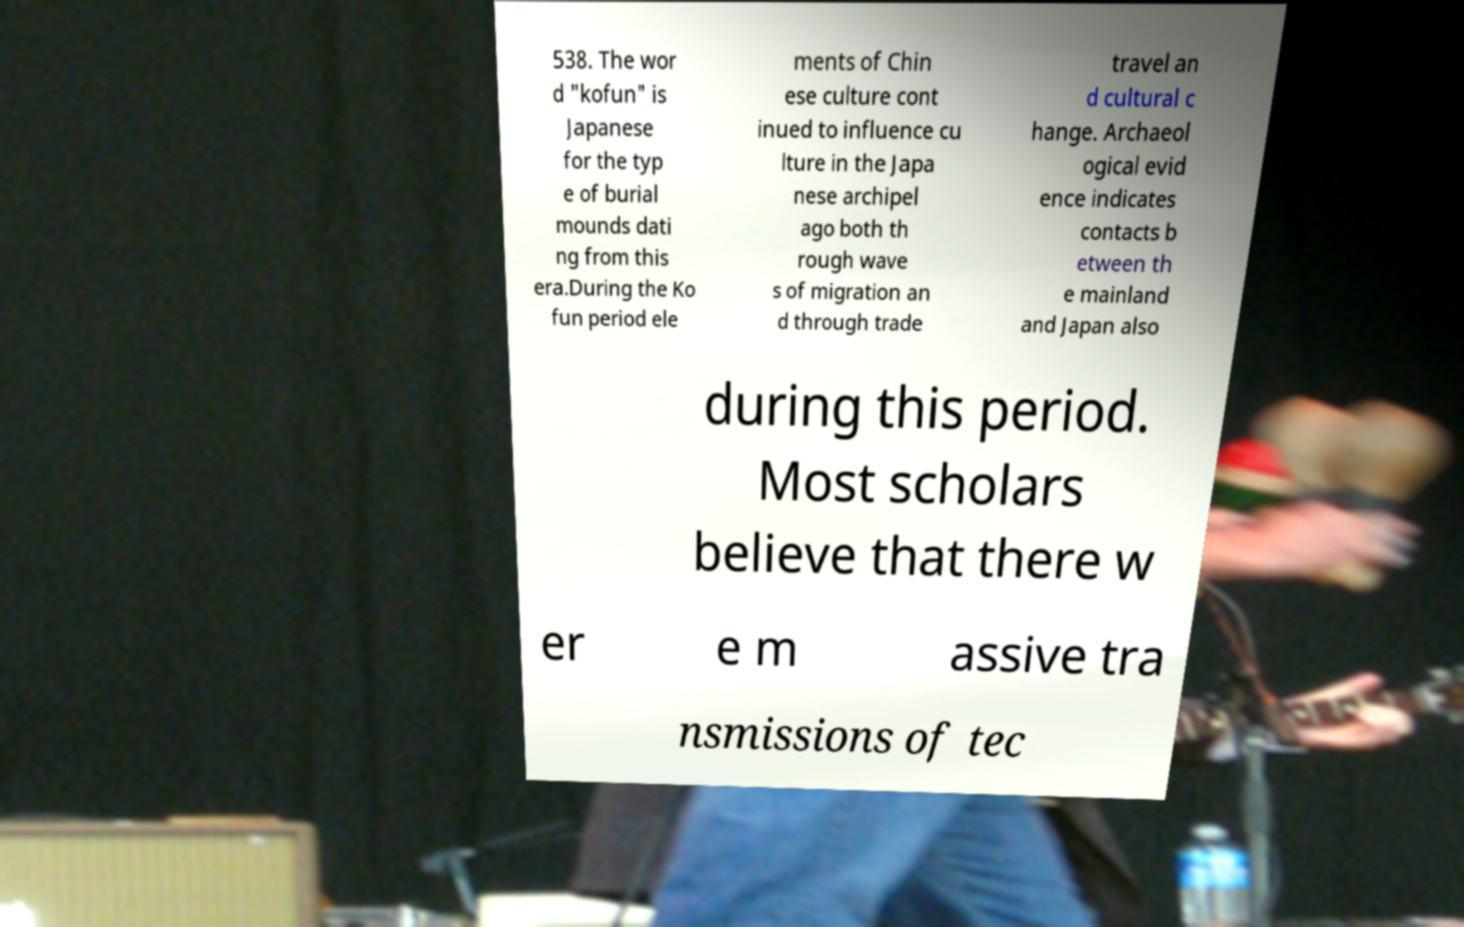I need the written content from this picture converted into text. Can you do that? 538. The wor d "kofun" is Japanese for the typ e of burial mounds dati ng from this era.During the Ko fun period ele ments of Chin ese culture cont inued to influence cu lture in the Japa nese archipel ago both th rough wave s of migration an d through trade travel an d cultural c hange. Archaeol ogical evid ence indicates contacts b etween th e mainland and Japan also during this period. Most scholars believe that there w er e m assive tra nsmissions of tec 